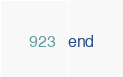Convert code to text. <code><loc_0><loc_0><loc_500><loc_500><_Ruby_>end
</code> 